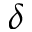<formula> <loc_0><loc_0><loc_500><loc_500>\delta</formula> 